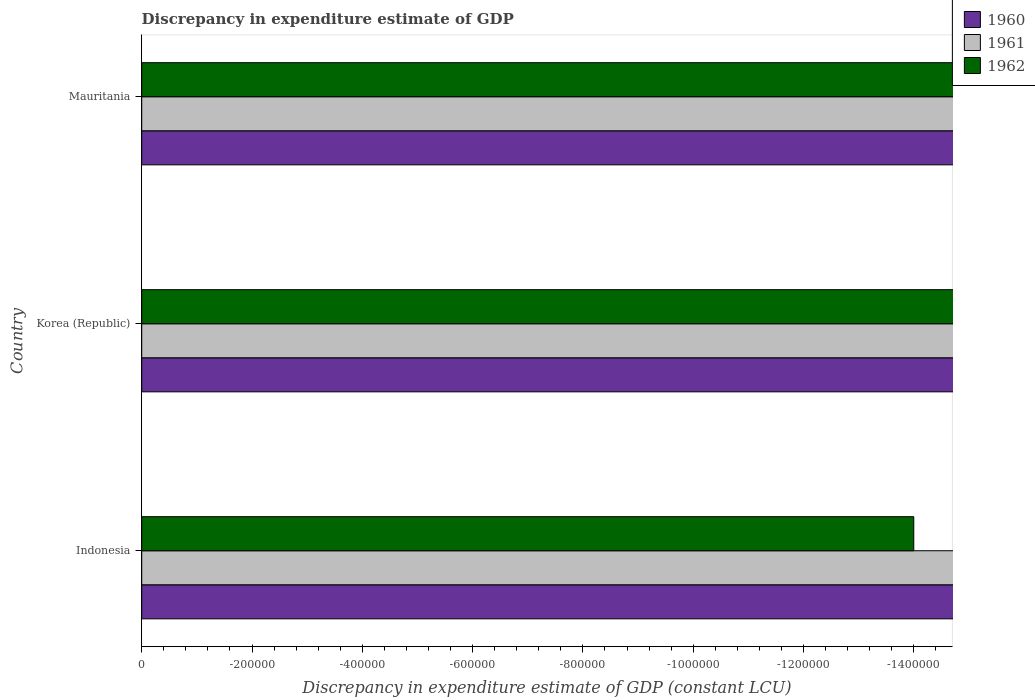How many different coloured bars are there?
Keep it short and to the point. 0. Are the number of bars on each tick of the Y-axis equal?
Ensure brevity in your answer.  Yes. Is it the case that in every country, the sum of the discrepancy in expenditure estimate of GDP in 1962 and discrepancy in expenditure estimate of GDP in 1960 is greater than the discrepancy in expenditure estimate of GDP in 1961?
Offer a terse response. No. Where does the legend appear in the graph?
Give a very brief answer. Top right. How many legend labels are there?
Keep it short and to the point. 3. What is the title of the graph?
Offer a very short reply. Discrepancy in expenditure estimate of GDP. What is the label or title of the X-axis?
Make the answer very short. Discrepancy in expenditure estimate of GDP (constant LCU). What is the label or title of the Y-axis?
Offer a terse response. Country. What is the Discrepancy in expenditure estimate of GDP (constant LCU) of 1960 in Indonesia?
Ensure brevity in your answer.  0. What is the Discrepancy in expenditure estimate of GDP (constant LCU) in 1961 in Indonesia?
Offer a very short reply. 0. What is the Discrepancy in expenditure estimate of GDP (constant LCU) in 1962 in Indonesia?
Your answer should be compact. 0. What is the Discrepancy in expenditure estimate of GDP (constant LCU) of 1962 in Mauritania?
Your response must be concise. 0. What is the total Discrepancy in expenditure estimate of GDP (constant LCU) of 1960 in the graph?
Ensure brevity in your answer.  0. What is the total Discrepancy in expenditure estimate of GDP (constant LCU) of 1961 in the graph?
Your answer should be very brief. 0. What is the total Discrepancy in expenditure estimate of GDP (constant LCU) of 1962 in the graph?
Give a very brief answer. 0. What is the average Discrepancy in expenditure estimate of GDP (constant LCU) of 1960 per country?
Your answer should be very brief. 0. 